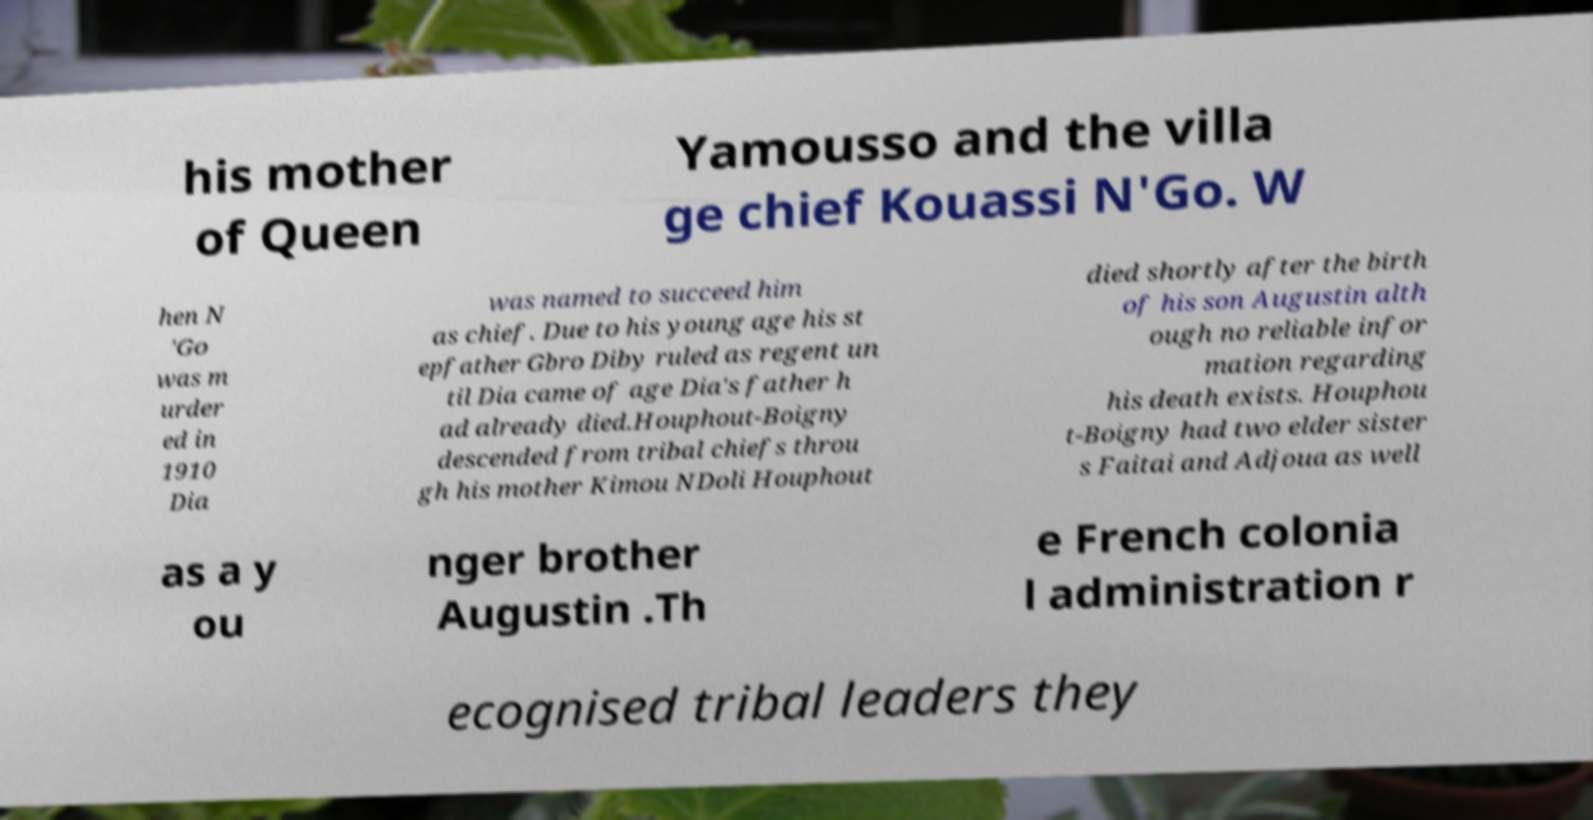Please read and relay the text visible in this image. What does it say? his mother of Queen Yamousso and the villa ge chief Kouassi N'Go. W hen N 'Go was m urder ed in 1910 Dia was named to succeed him as chief. Due to his young age his st epfather Gbro Diby ruled as regent un til Dia came of age Dia's father h ad already died.Houphout-Boigny descended from tribal chiefs throu gh his mother Kimou NDoli Houphout died shortly after the birth of his son Augustin alth ough no reliable infor mation regarding his death exists. Houphou t-Boigny had two elder sister s Faitai and Adjoua as well as a y ou nger brother Augustin .Th e French colonia l administration r ecognised tribal leaders they 